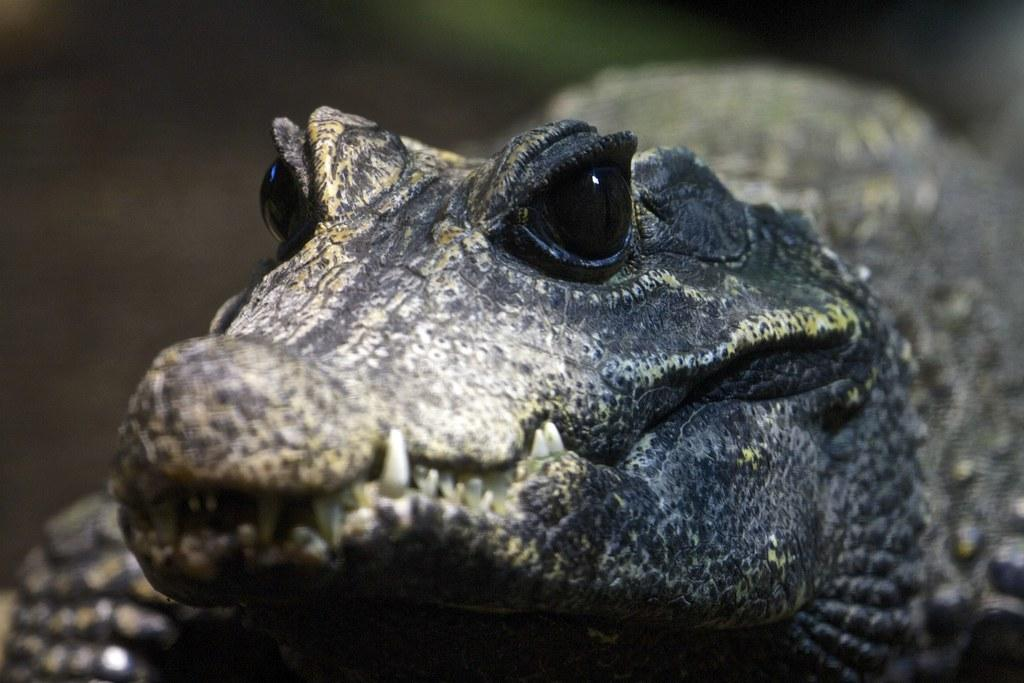What type of animal is in the image? There is an alligator in the image. What type of tray is being used to serve the alligator in the image? There is no tray present in the image, as it features an alligator and not a meal being served. 